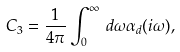Convert formula to latex. <formula><loc_0><loc_0><loc_500><loc_500>C _ { 3 } = \frac { 1 } { 4 \pi } \int _ { 0 } ^ { \infty } \, d \omega \alpha _ { d } ( i \omega ) ,</formula> 